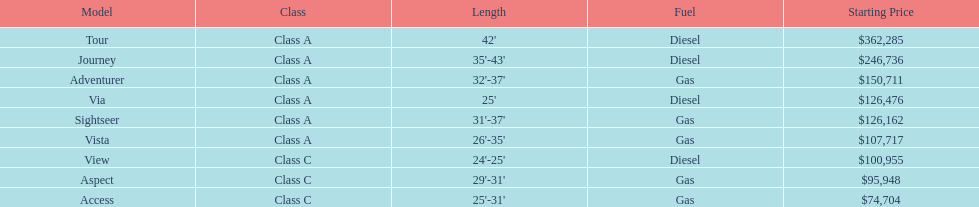How many models are available in lengths longer than 30 feet? 7. 